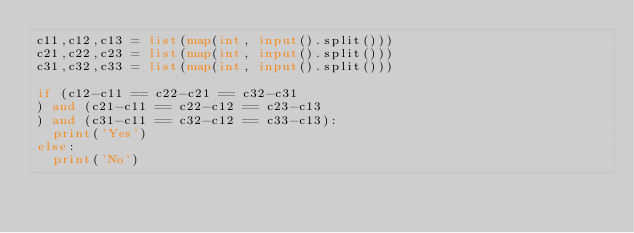Convert code to text. <code><loc_0><loc_0><loc_500><loc_500><_Python_>c11,c12,c13 = list(map(int, input().split()))
c21,c22,c23 = list(map(int, input().split()))
c31,c32,c33 = list(map(int, input().split()))

if (c12-c11 == c22-c21 == c32-c31
) and (c21-c11 == c22-c12 == c23-c13
) and (c31-c11 == c32-c12 == c33-c13):
  print('Yes')
else:
  print('No')</code> 